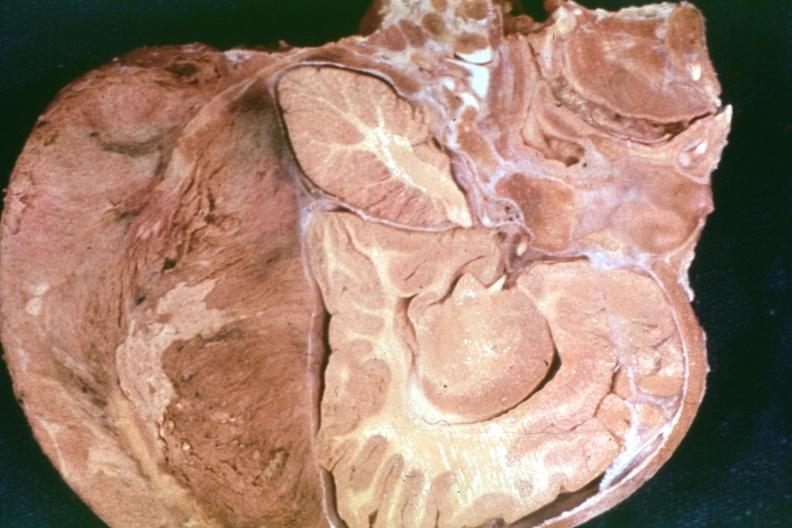s hemisection of nose present?
Answer the question using a single word or phrase. No 